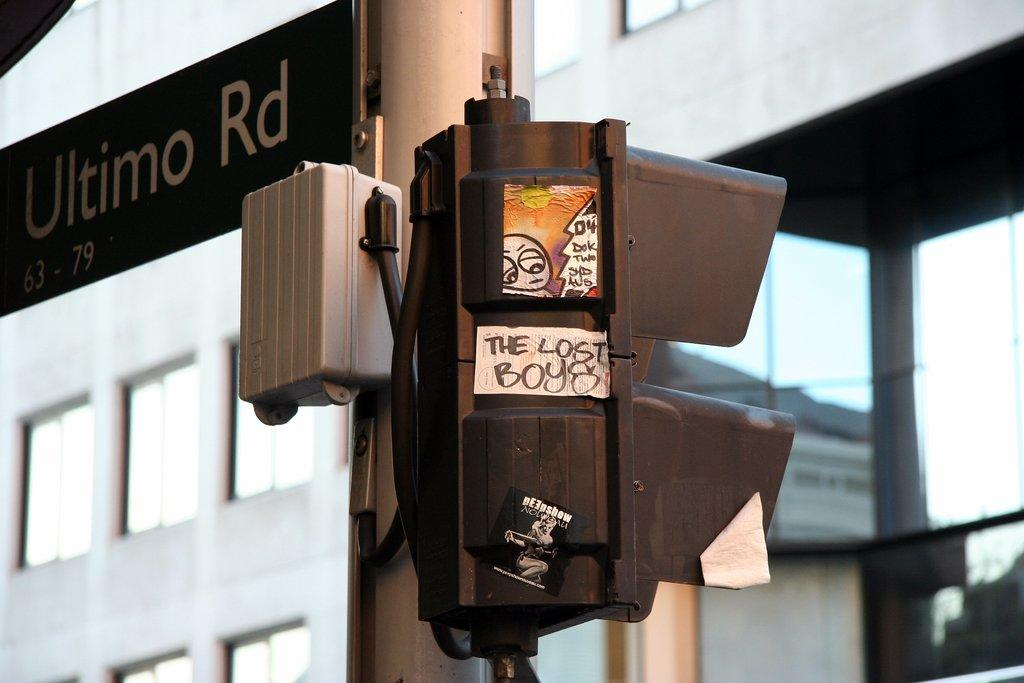What is the main object in the image? There is a traffic signal in the image. How is the traffic signal supported? The traffic signal is attached to a pole. What other object can be seen in the image? There is a name board in the image. What can be seen in the background of the image? There is a building with windows in the background of the image. What scientific discoveries are being made in space in the image? There is no reference to scientific discoveries or space in the image; it features a traffic signal, a name board, and a building with windows. 